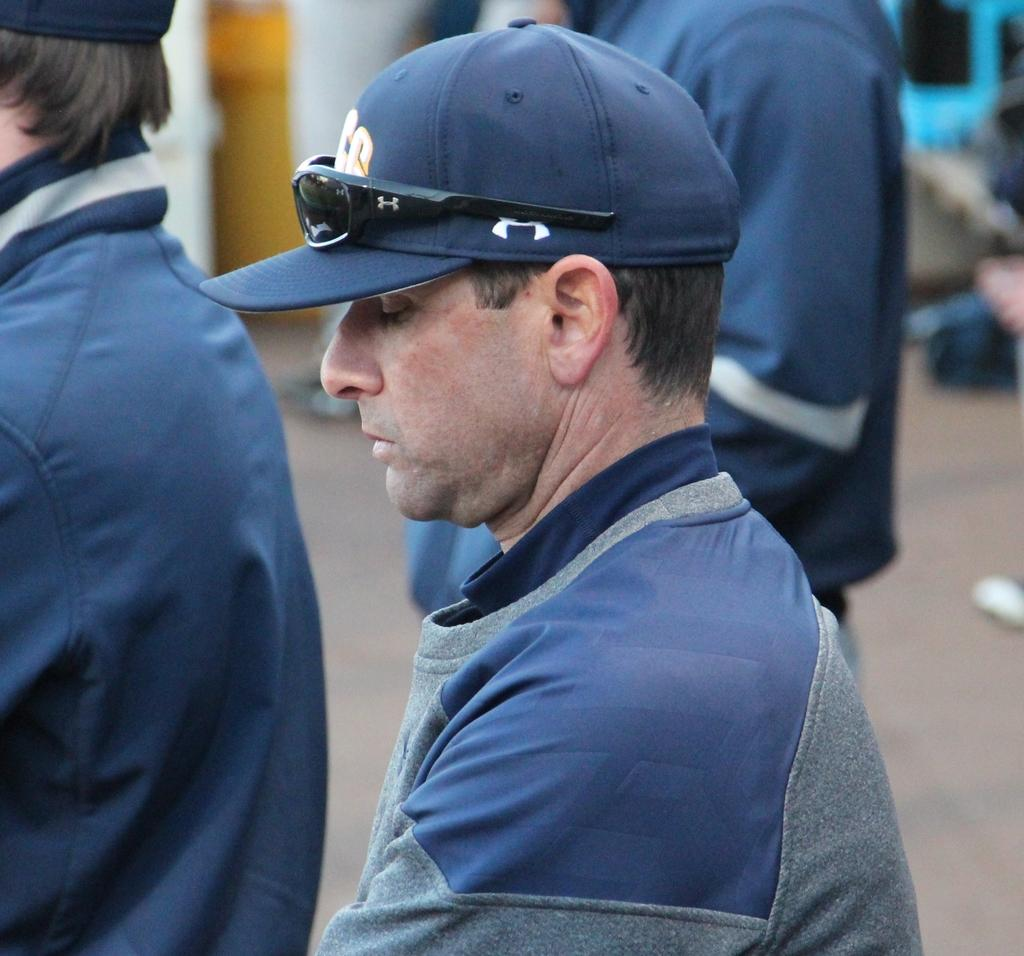How many people are in the image? There are three people standing in the image. Can you describe the clothing of one of the individuals? A man is wearing a jacket and cap. What is a distinctive feature of the man's cap? The man has black shades on his cap. What type of insect can be seen crawling on the crate in the image? There is no crate or insect present in the image. 